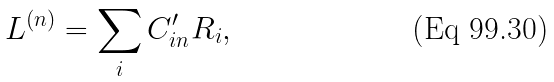<formula> <loc_0><loc_0><loc_500><loc_500>L ^ { ( n ) } = \sum _ { i } C ^ { \prime } _ { i n } R _ { i } ,</formula> 